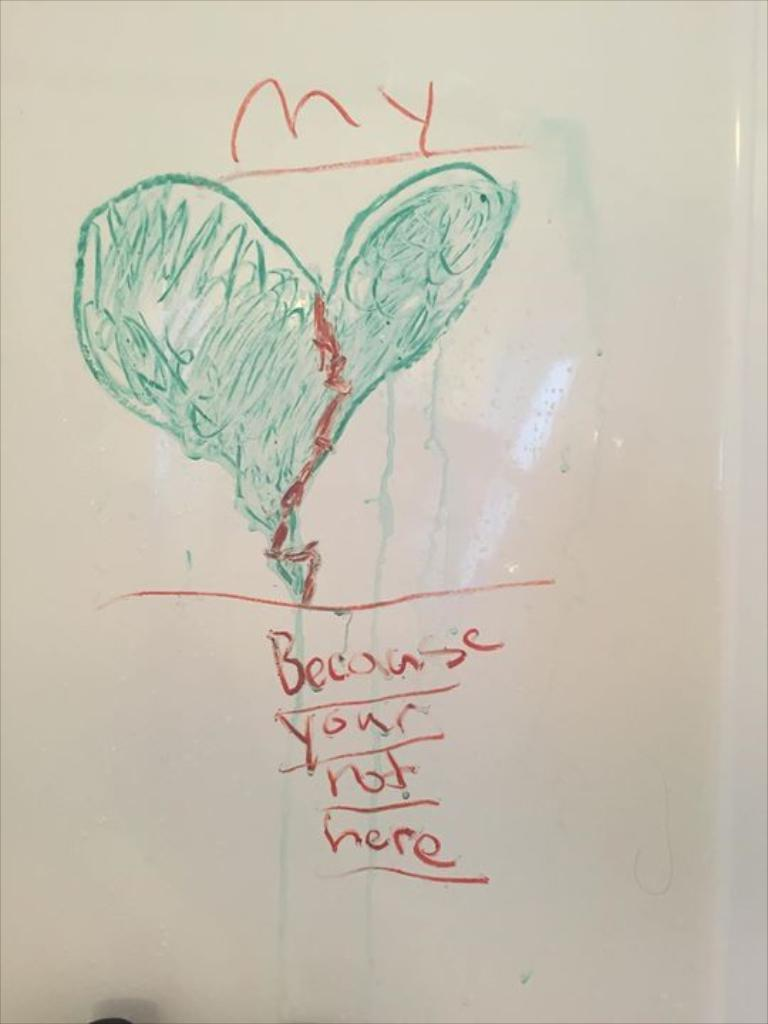<image>
Present a compact description of the photo's key features. A red and green heard drawing that says their heart is broken because you're not here. 